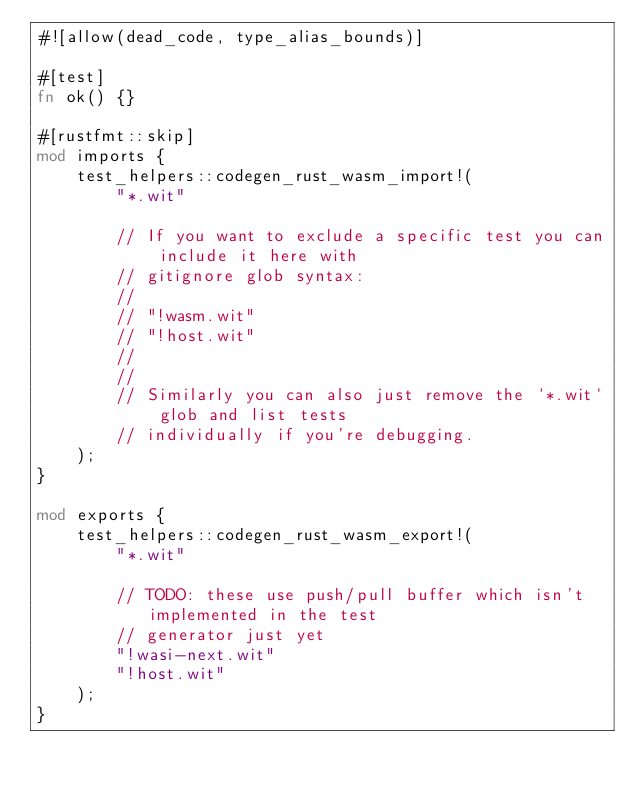Convert code to text. <code><loc_0><loc_0><loc_500><loc_500><_Rust_>#![allow(dead_code, type_alias_bounds)]

#[test]
fn ok() {}

#[rustfmt::skip]
mod imports {
    test_helpers::codegen_rust_wasm_import!(
        "*.wit"

        // If you want to exclude a specific test you can include it here with
        // gitignore glob syntax:
        //
        // "!wasm.wit"
        // "!host.wit"
        //
        //
        // Similarly you can also just remove the `*.wit` glob and list tests
        // individually if you're debugging.
    );
}

mod exports {
    test_helpers::codegen_rust_wasm_export!(
        "*.wit"

        // TODO: these use push/pull buffer which isn't implemented in the test
        // generator just yet
        "!wasi-next.wit"
        "!host.wit"
    );
}
</code> 